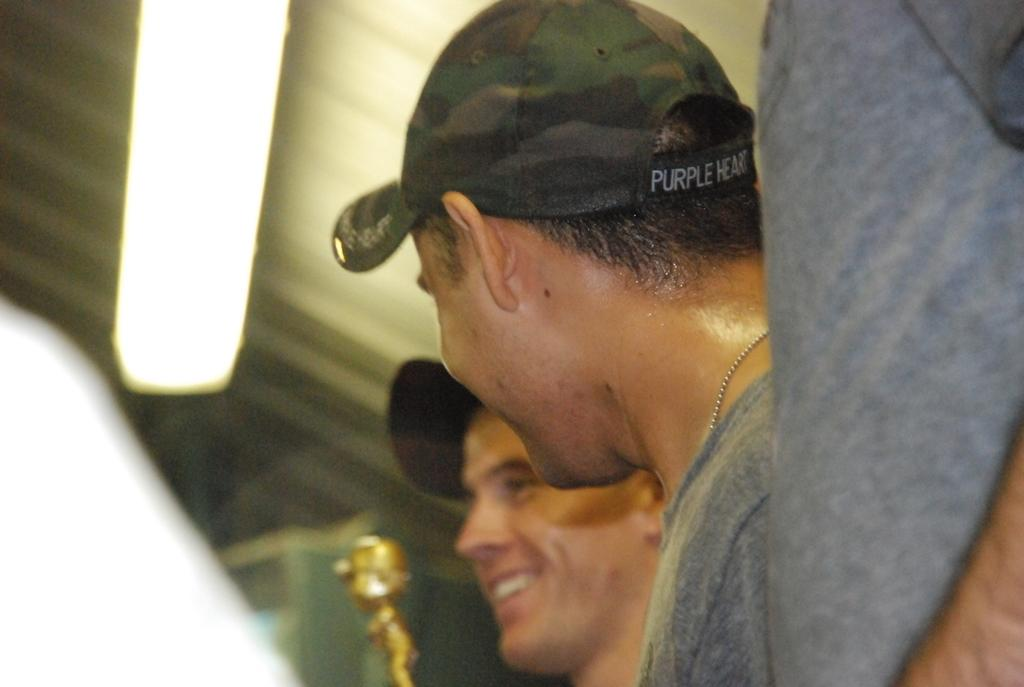How many people are in the image? There are two persons in the image. What expressions do the persons have on their faces? The persons are wearing smiles on their faces. What object is beside the persons? There is a doll beside the persons. What can be seen in the background of the image? There is a wall in the background of the image. Where is the light located in the image? There is a light on the roof in the image. What type of error can be seen in the image? There is no error present in the image. What type of coil is used to create the doll's hair in the image? The image does not show the doll's hair or any coils used to create it. 